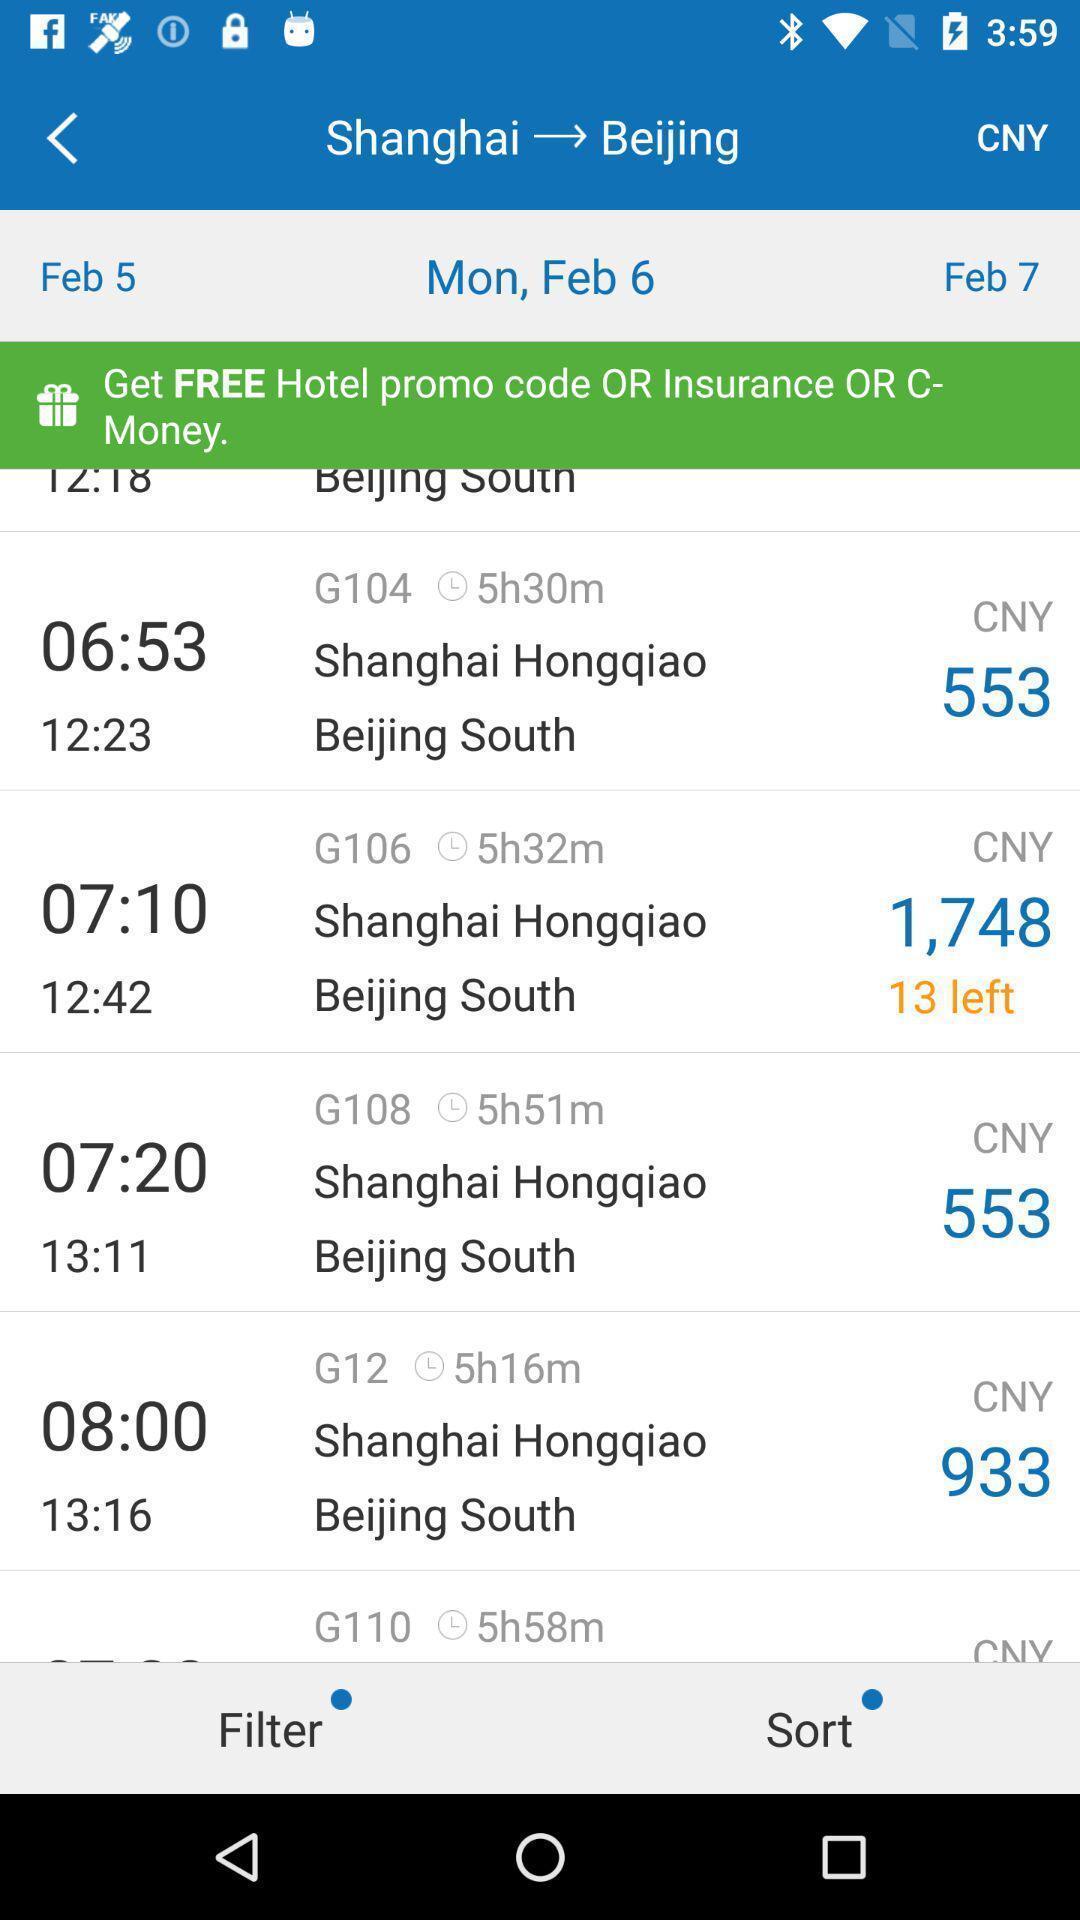Tell me what you see in this picture. Screen shows hotel details in travel app. 